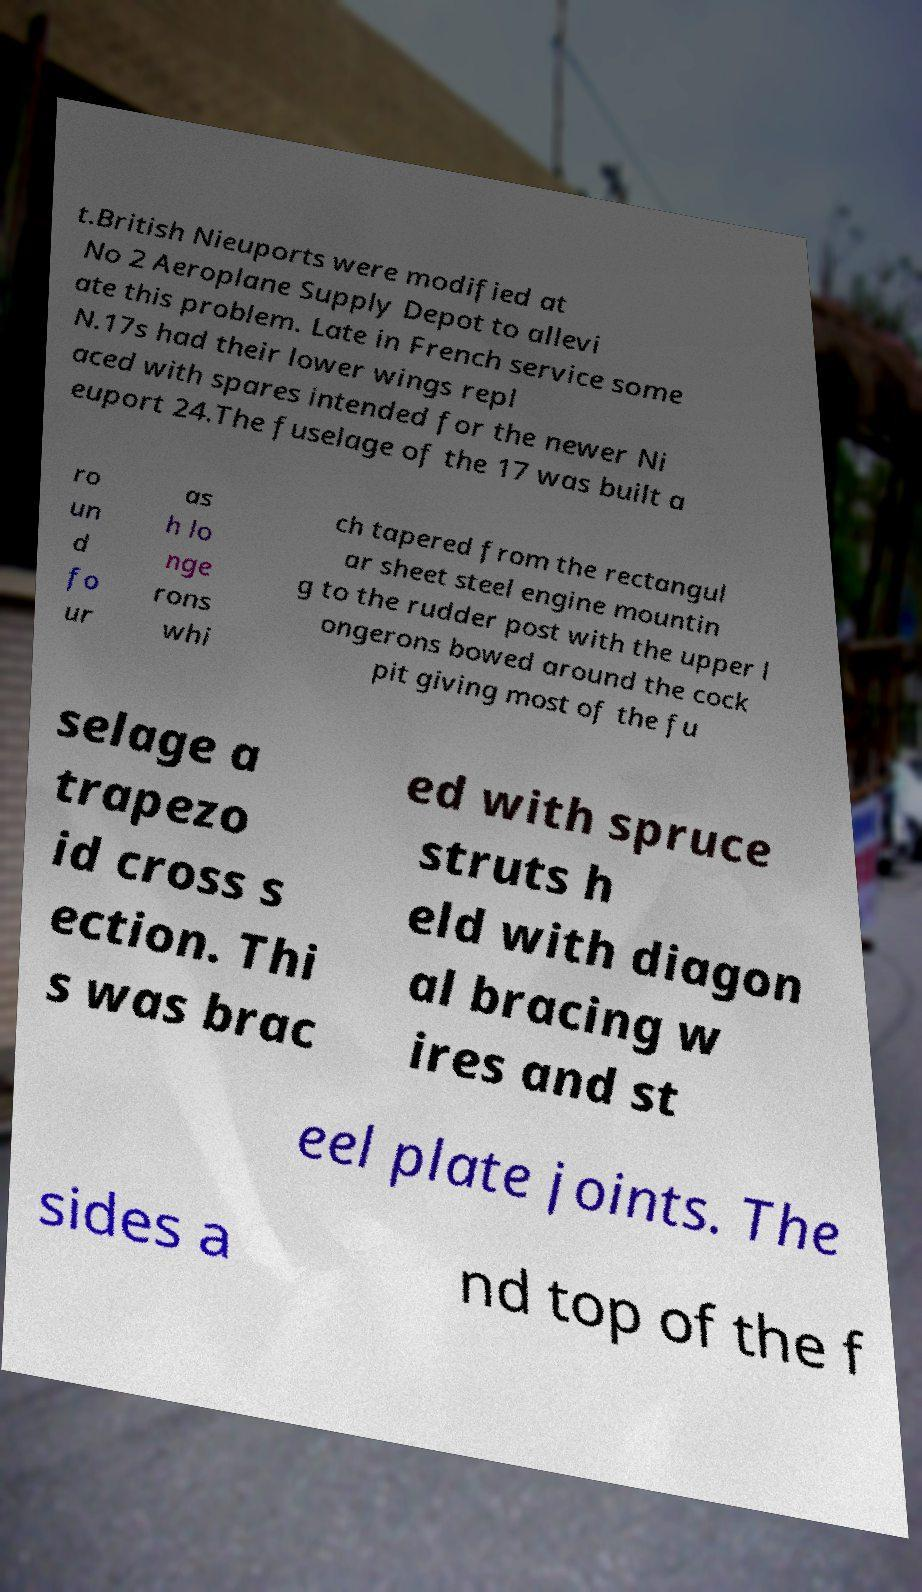Can you accurately transcribe the text from the provided image for me? t.British Nieuports were modified at No 2 Aeroplane Supply Depot to allevi ate this problem. Late in French service some N.17s had their lower wings repl aced with spares intended for the newer Ni euport 24.The fuselage of the 17 was built a ro un d fo ur as h lo nge rons whi ch tapered from the rectangul ar sheet steel engine mountin g to the rudder post with the upper l ongerons bowed around the cock pit giving most of the fu selage a trapezo id cross s ection. Thi s was brac ed with spruce struts h eld with diagon al bracing w ires and st eel plate joints. The sides a nd top of the f 